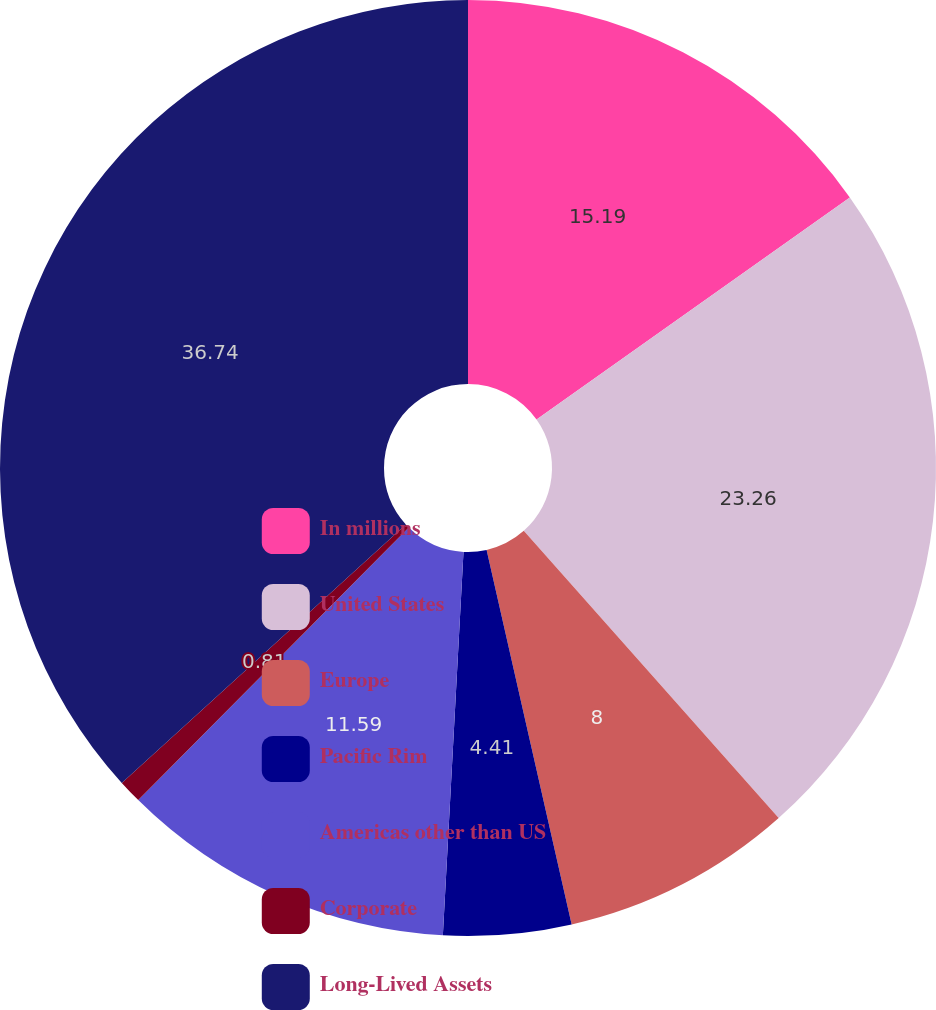Convert chart. <chart><loc_0><loc_0><loc_500><loc_500><pie_chart><fcel>In millions<fcel>United States<fcel>Europe<fcel>Pacific Rim<fcel>Americas other than US<fcel>Corporate<fcel>Long-Lived Assets<nl><fcel>15.19%<fcel>23.26%<fcel>8.0%<fcel>4.41%<fcel>11.59%<fcel>0.81%<fcel>36.75%<nl></chart> 